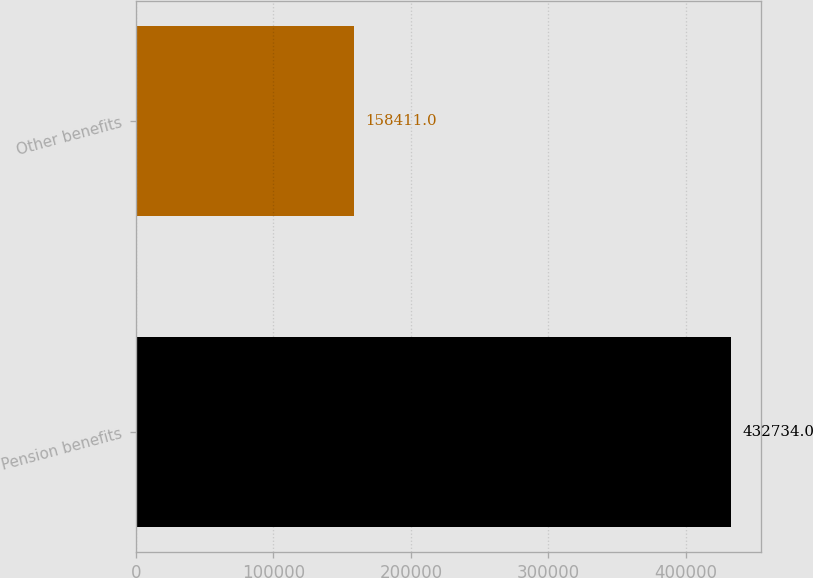<chart> <loc_0><loc_0><loc_500><loc_500><bar_chart><fcel>Pension benefits<fcel>Other benefits<nl><fcel>432734<fcel>158411<nl></chart> 